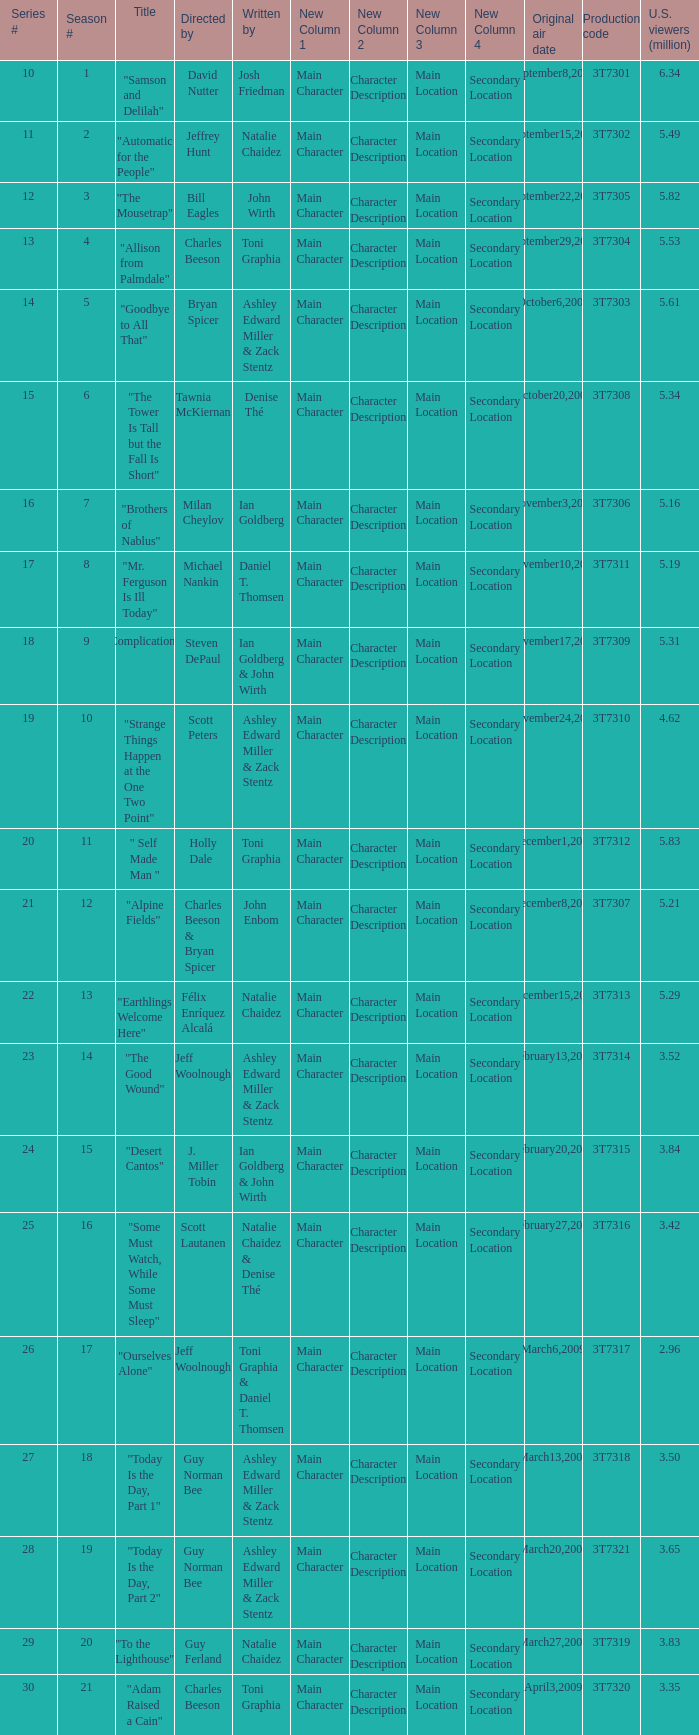How many viewers did the episode directed by David Nutter draw in? 6.34. 